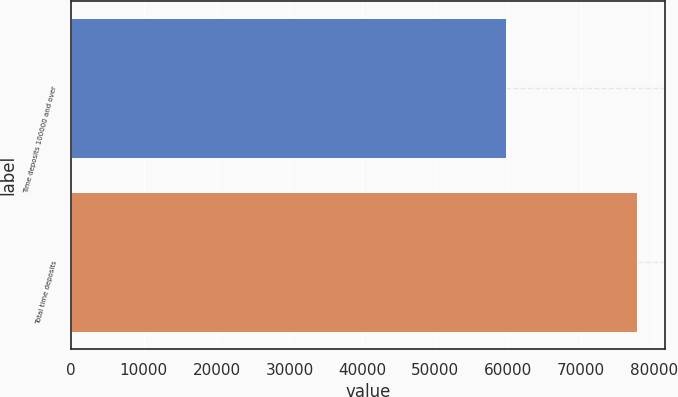<chart> <loc_0><loc_0><loc_500><loc_500><bar_chart><fcel>Time deposits 100000 and over<fcel>Total time deposits<nl><fcel>59703<fcel>77653<nl></chart> 